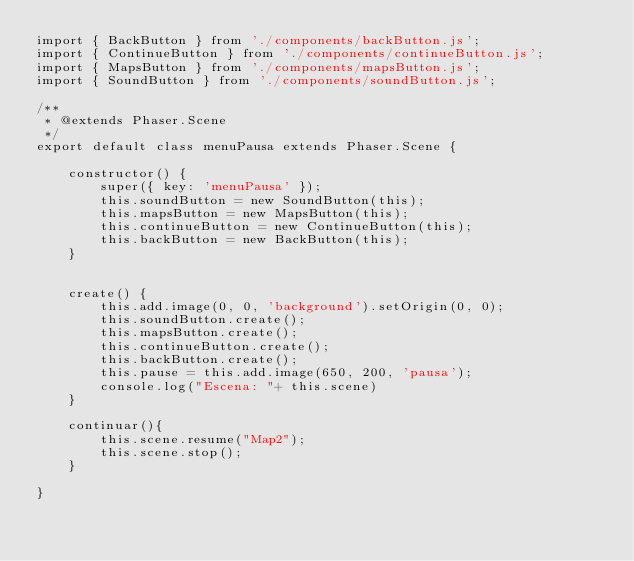<code> <loc_0><loc_0><loc_500><loc_500><_JavaScript_>import { BackButton } from './components/backButton.js';
import { ContinueButton } from './components/continueButton.js';
import { MapsButton } from './components/mapsButton.js';
import { SoundButton } from './components/soundButton.js';

/**
 * @extends Phaser.Scene
 */
export default class menuPausa extends Phaser.Scene {

    constructor() {
        super({ key: 'menuPausa' });
        this.soundButton = new SoundButton(this);
        this.mapsButton = new MapsButton(this);
        this.continueButton = new ContinueButton(this);
        this.backButton = new BackButton(this);
    }
    
      
    create() {
        this.add.image(0, 0, 'background').setOrigin(0, 0);
        this.soundButton.create();
        this.mapsButton.create();
        this.continueButton.create();
        this.backButton.create();
        this.pause = this.add.image(650, 200, 'pausa');
        console.log("Escena: "+ this.scene)
    }

    continuar(){
        this.scene.resume("Map2");
        this.scene.stop();
    }

}
</code> 